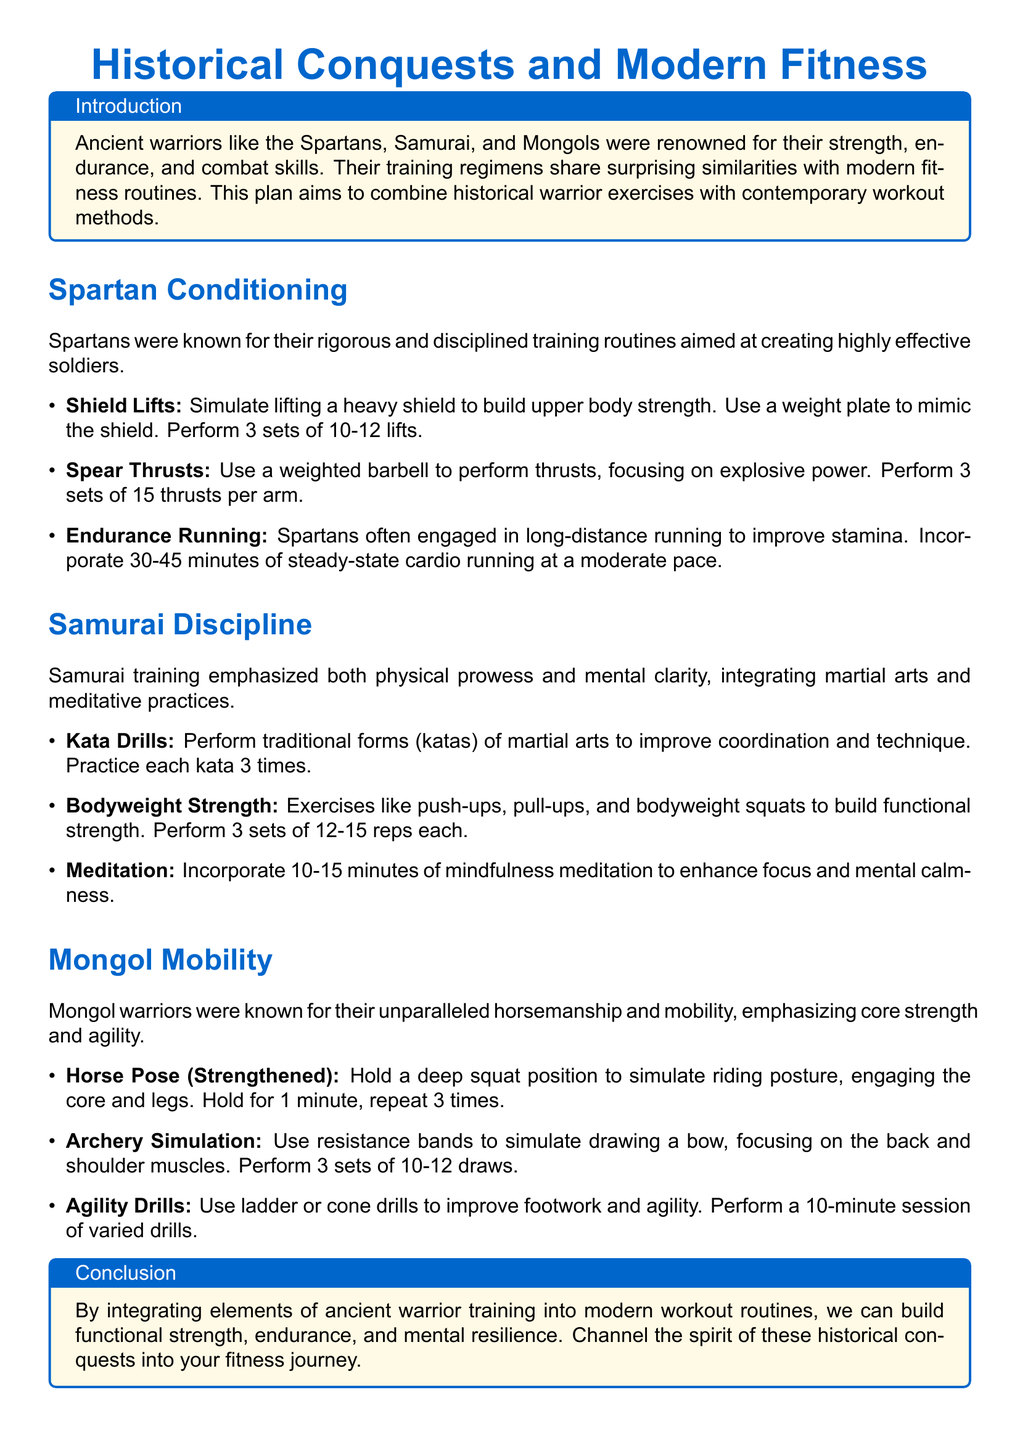what is the primary focus of the workout plan? The workout plan focuses on integrating historical warrior exercises with modern workout methods to enhance fitness.
Answer: integrating historical warrior exercises how many sets of shield lifts should be performed? The document states that shield lifts should be performed for 3 sets.
Answer: 3 sets what type of meditation is recommended in the Samurai section? The document recommends mindfulness meditation to enhance focus and mental calmness.
Answer: mindfulness meditation how long should endurance running be incorporated? The document suggests incorporating 30-45 minutes of steady-state cardio running.
Answer: 30-45 minutes what exercise simulates drawing a bow in the Mongol section? The document mentions using resistance bands to simulate drawing a bow.
Answer: resistance bands which ancient warrior training emphasized mental clarity? The Samurai training emphasized both physical prowess and mental clarity.
Answer: Samurai how many times should each kata be practiced? The document states that each kata should be practiced 3 times.
Answer: 3 times what is the main benefit of including agility drills? Agility drills improve footwork and agility, as mentioned in the Mongol section.
Answer: footwork and agility what type of exercises build functional strength in the Samurai training? Bodyweight strength exercises like push-ups, pull-ups, and bodyweight squats build functional strength.
Answer: Bodyweight strength exercises 